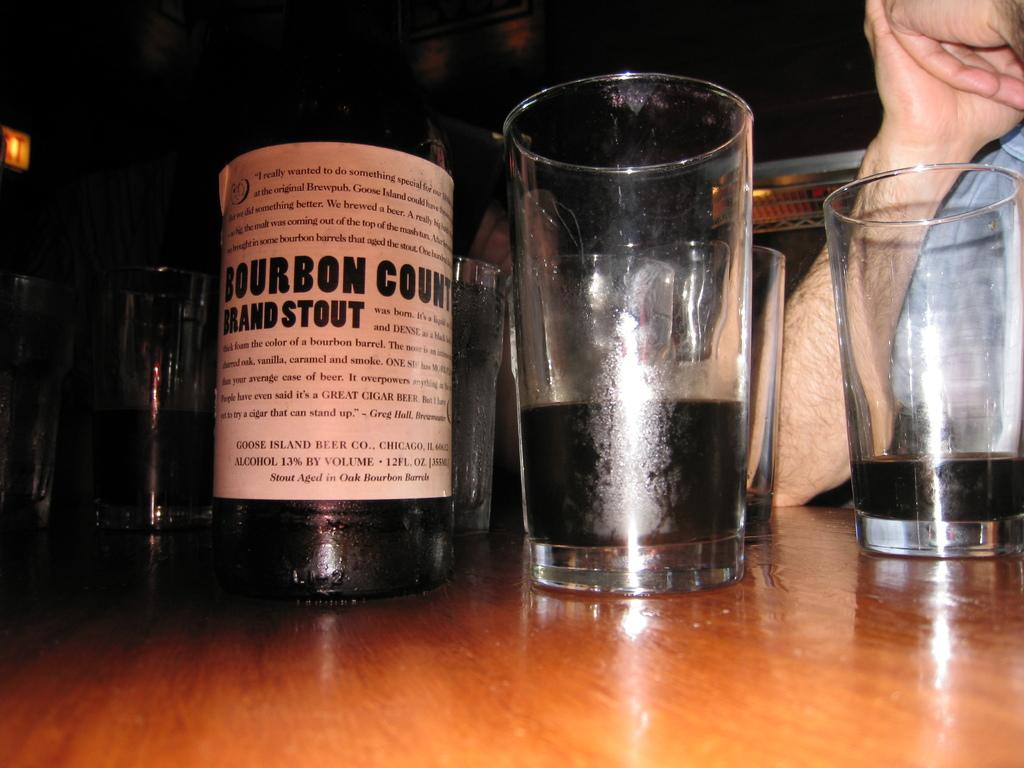<image>
Relay a brief, clear account of the picture shown. A bottle of Bourbon Brand Stout manufactured by Goose Island Beer Co. sits on a table next to glasses. 